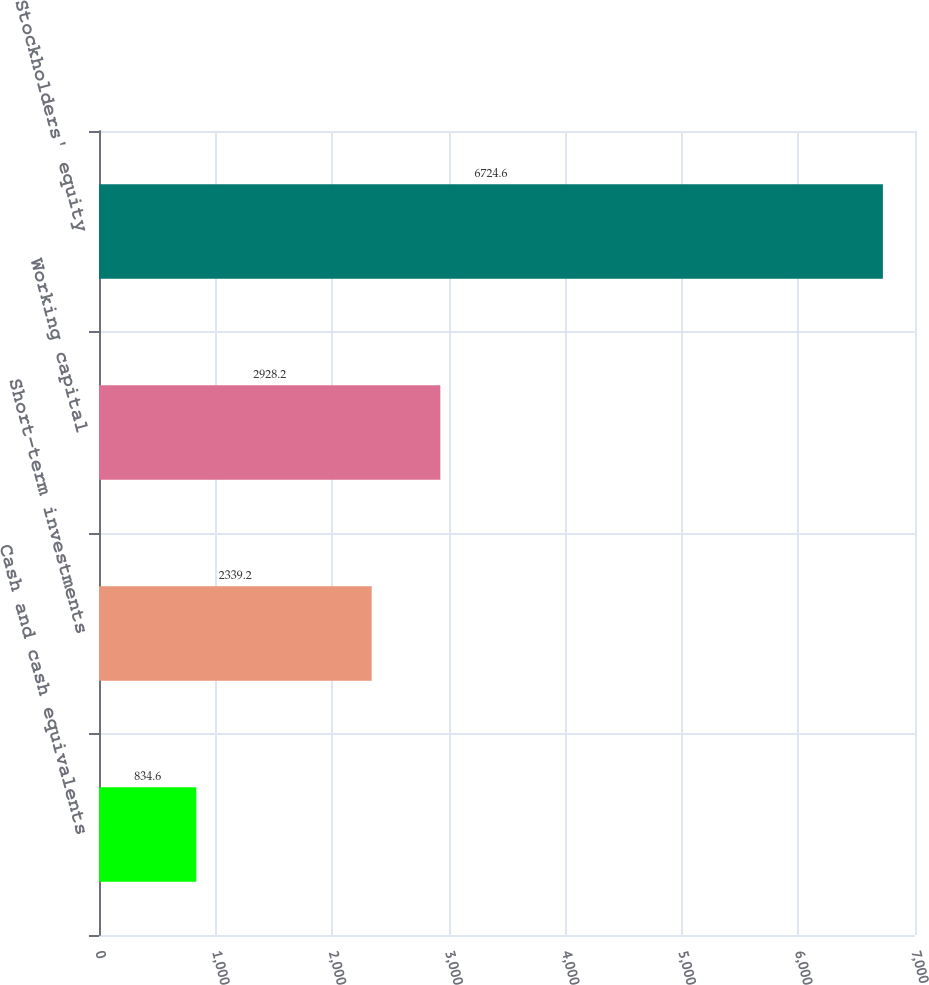Convert chart to OTSL. <chart><loc_0><loc_0><loc_500><loc_500><bar_chart><fcel>Cash and cash equivalents<fcel>Short-term investments<fcel>Working capital<fcel>Stockholders' equity<nl><fcel>834.6<fcel>2339.2<fcel>2928.2<fcel>6724.6<nl></chart> 